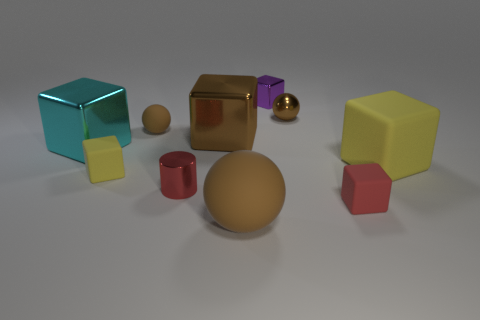How many brown balls must be subtracted to get 1 brown balls? 2 Subtract 1 blocks. How many blocks are left? 5 Subtract all brown blocks. How many blocks are left? 5 Subtract all purple cubes. How many cubes are left? 5 Subtract all green cubes. Subtract all blue cylinders. How many cubes are left? 6 Subtract all cylinders. How many objects are left? 9 Subtract 0 blue spheres. How many objects are left? 10 Subtract all small purple metal cubes. Subtract all blue metal cubes. How many objects are left? 9 Add 3 tiny spheres. How many tiny spheres are left? 5 Add 1 tiny red cylinders. How many tiny red cylinders exist? 2 